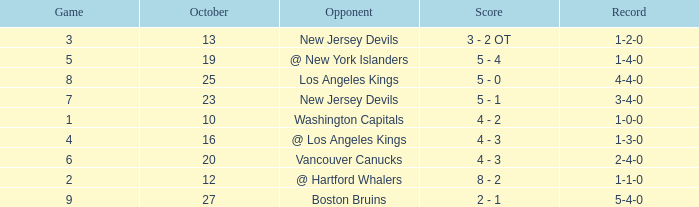What was the average game with a record of 4-4-0? 8.0. Would you be able to parse every entry in this table? {'header': ['Game', 'October', 'Opponent', 'Score', 'Record'], 'rows': [['3', '13', 'New Jersey Devils', '3 - 2 OT', '1-2-0'], ['5', '19', '@ New York Islanders', '5 - 4', '1-4-0'], ['8', '25', 'Los Angeles Kings', '5 - 0', '4-4-0'], ['7', '23', 'New Jersey Devils', '5 - 1', '3-4-0'], ['1', '10', 'Washington Capitals', '4 - 2', '1-0-0'], ['4', '16', '@ Los Angeles Kings', '4 - 3', '1-3-0'], ['6', '20', 'Vancouver Canucks', '4 - 3', '2-4-0'], ['2', '12', '@ Hartford Whalers', '8 - 2', '1-1-0'], ['9', '27', 'Boston Bruins', '2 - 1', '5-4-0']]} 